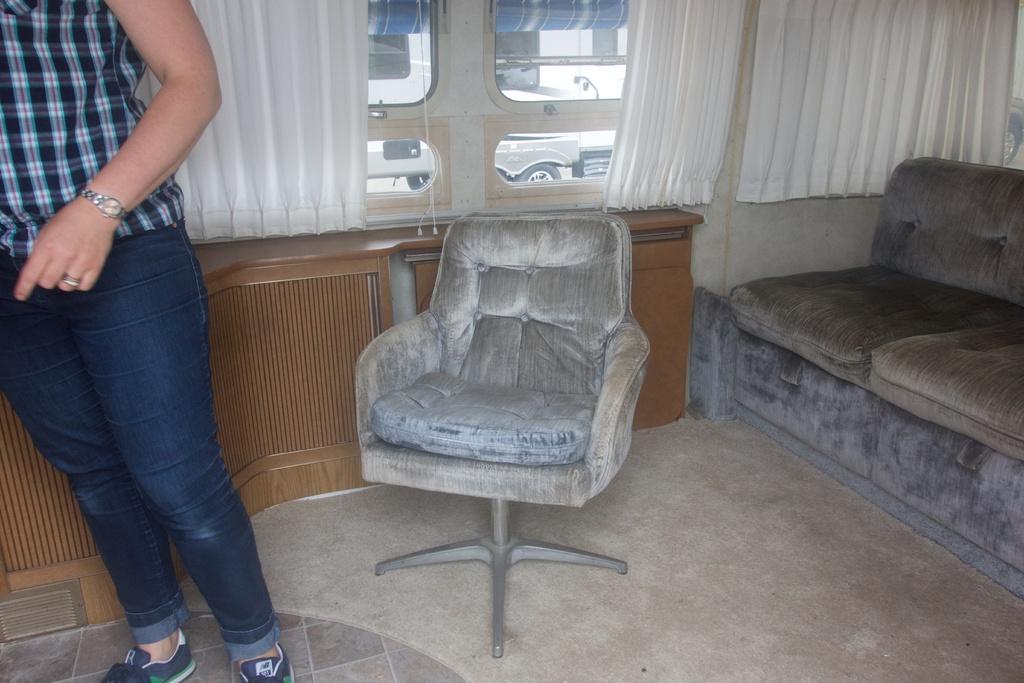In one or two sentences, can you explain what this image depicts? In this picture to the left,there is a woman who is wearing a blue top and a jean is standing. She is wearing a watch on her wrist. There is a chair. To the right, there is a sofa. There are white color curtains. At the background ,there is a vehicle. 